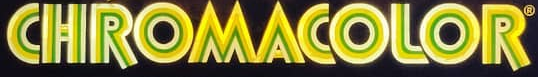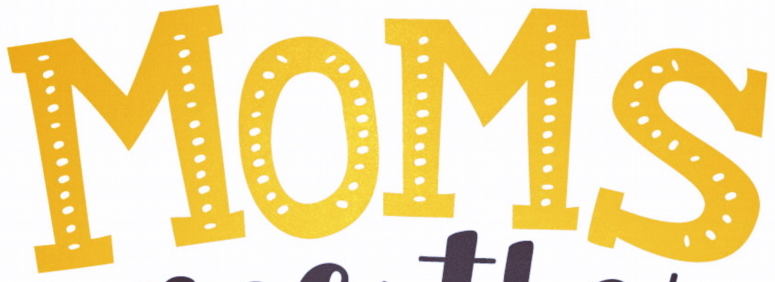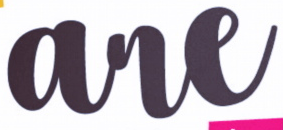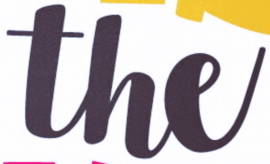Read the text content from these images in order, separated by a semicolon. CHROMACOLOR; MOMS; are; the 